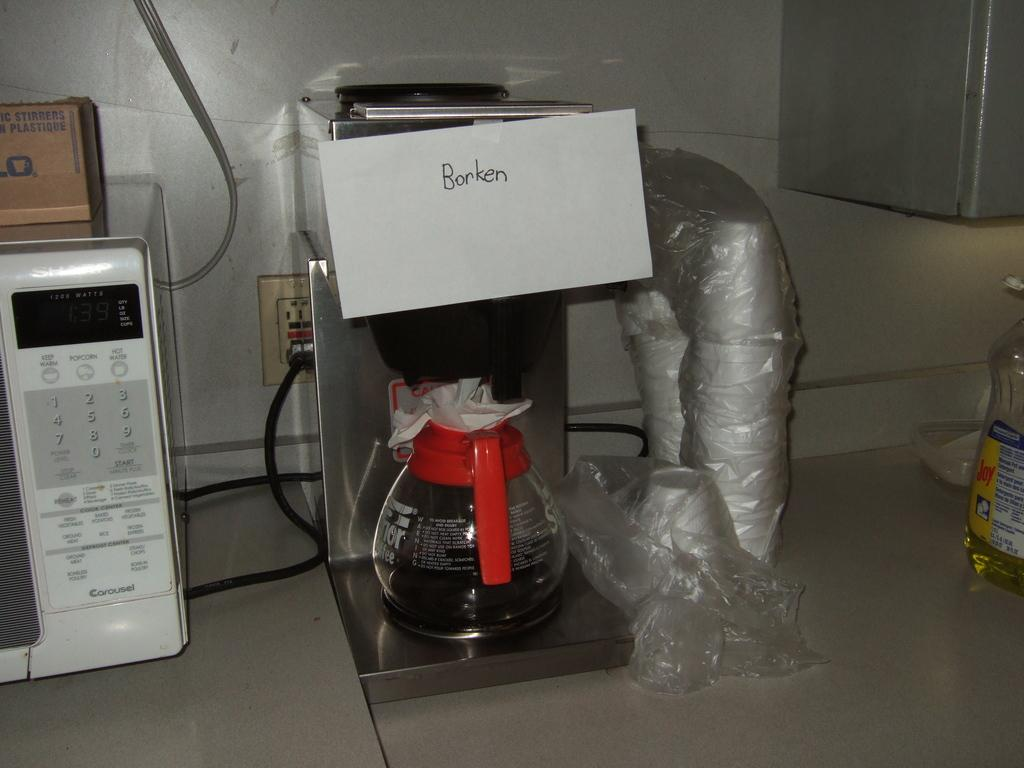<image>
Summarize the visual content of the image. a sign above a coffee machine that says 'broken' 